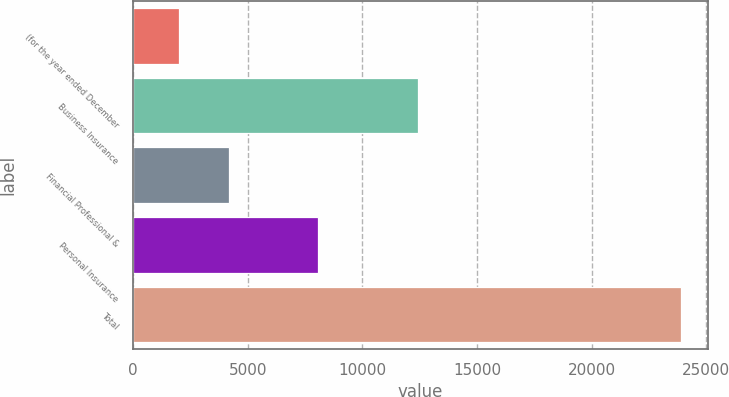Convert chart to OTSL. <chart><loc_0><loc_0><loc_500><loc_500><bar_chart><fcel>(for the year ended December<fcel>Business Insurance<fcel>Financial Professional &<fcel>Personal Insurance<fcel>Total<nl><fcel>2011<fcel>12418<fcel>4198.6<fcel>8061<fcel>23887<nl></chart> 